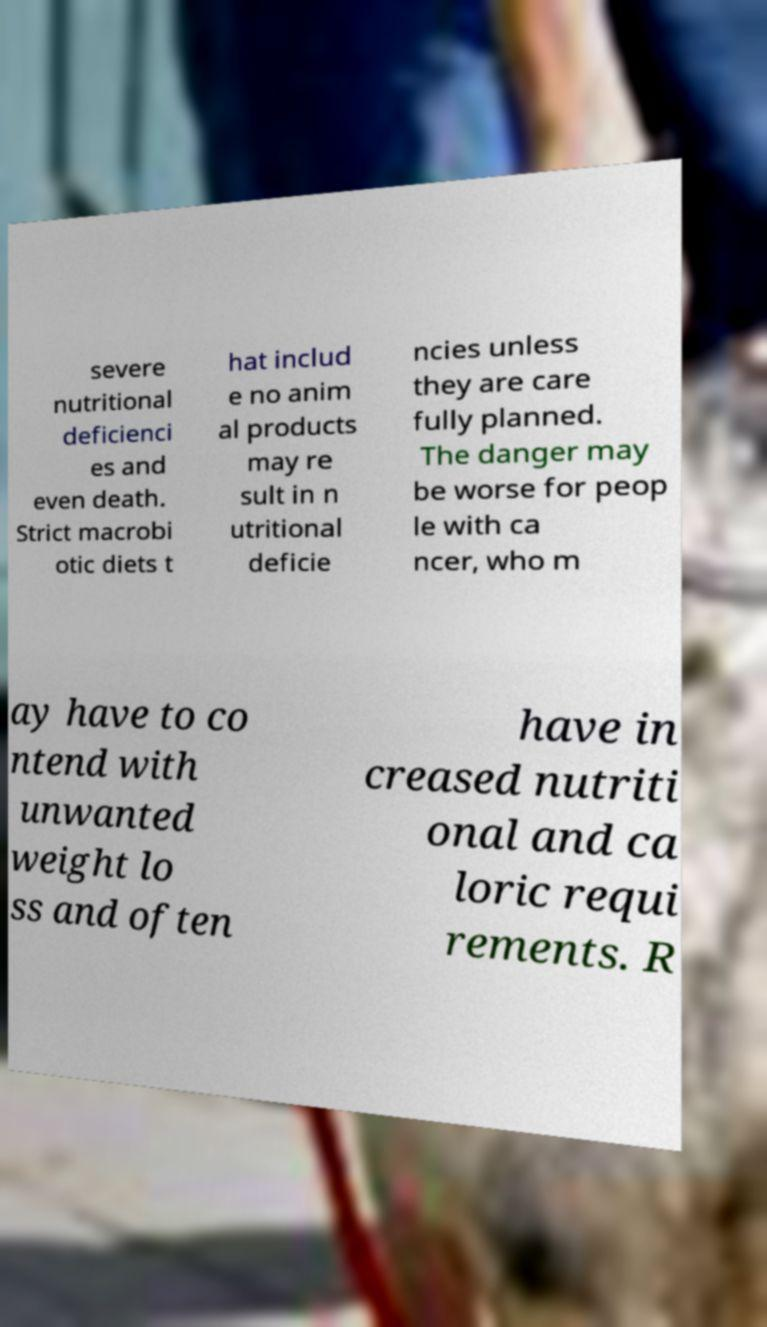I need the written content from this picture converted into text. Can you do that? severe nutritional deficienci es and even death. Strict macrobi otic diets t hat includ e no anim al products may re sult in n utritional deficie ncies unless they are care fully planned. The danger may be worse for peop le with ca ncer, who m ay have to co ntend with unwanted weight lo ss and often have in creased nutriti onal and ca loric requi rements. R 